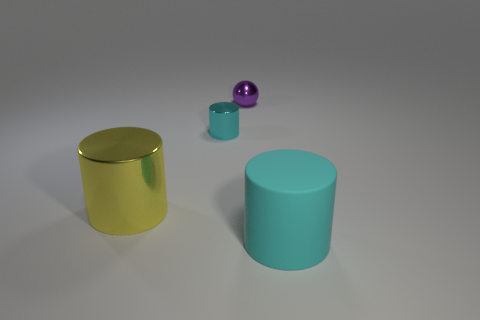Subtract all blue cylinders. Subtract all green cubes. How many cylinders are left? 3 Add 1 cyan metal things. How many objects exist? 5 Subtract all balls. How many objects are left? 3 Add 2 cyan matte things. How many cyan matte things exist? 3 Subtract 0 yellow balls. How many objects are left? 4 Subtract all balls. Subtract all small cyan metallic cylinders. How many objects are left? 2 Add 4 small balls. How many small balls are left? 5 